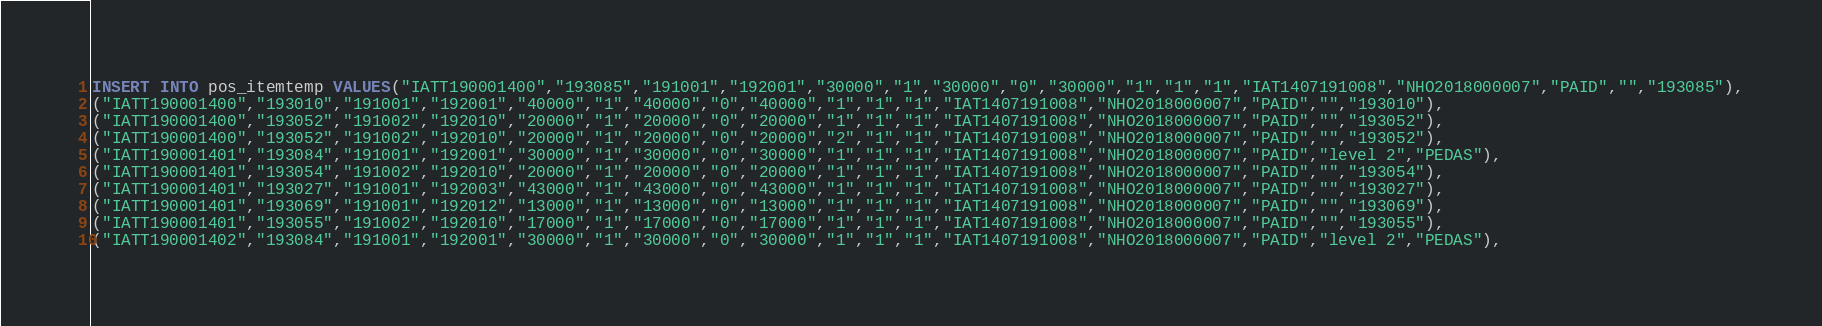Convert code to text. <code><loc_0><loc_0><loc_500><loc_500><_SQL_>INSERT INTO pos_itemtemp VALUES("IATT190001400","193085","191001","192001","30000","1","30000","0","30000","1","1","1","IAT1407191008","NHO2018000007","PAID","","193085"),
("IATT190001400","193010","191001","192001","40000","1","40000","0","40000","1","1","1","IAT1407191008","NHO2018000007","PAID","","193010"),
("IATT190001400","193052","191002","192010","20000","1","20000","0","20000","1","1","1","IAT1407191008","NHO2018000007","PAID","","193052"),
("IATT190001400","193052","191002","192010","20000","1","20000","0","20000","2","1","1","IAT1407191008","NHO2018000007","PAID","","193052"),
("IATT190001401","193084","191001","192001","30000","1","30000","0","30000","1","1","1","IAT1407191008","NHO2018000007","PAID","level 2","PEDAS"),
("IATT190001401","193054","191002","192010","20000","1","20000","0","20000","1","1","1","IAT1407191008","NHO2018000007","PAID","","193054"),
("IATT190001401","193027","191001","192003","43000","1","43000","0","43000","1","1","1","IAT1407191008","NHO2018000007","PAID","","193027"),
("IATT190001401","193069","191001","192012","13000","1","13000","0","13000","1","1","1","IAT1407191008","NHO2018000007","PAID","","193069"),
("IATT190001401","193055","191002","192010","17000","1","17000","0","17000","1","1","1","IAT1407191008","NHO2018000007","PAID","","193055"),
("IATT190001402","193084","191001","192001","30000","1","30000","0","30000","1","1","1","IAT1407191008","NHO2018000007","PAID","level 2","PEDAS"),</code> 